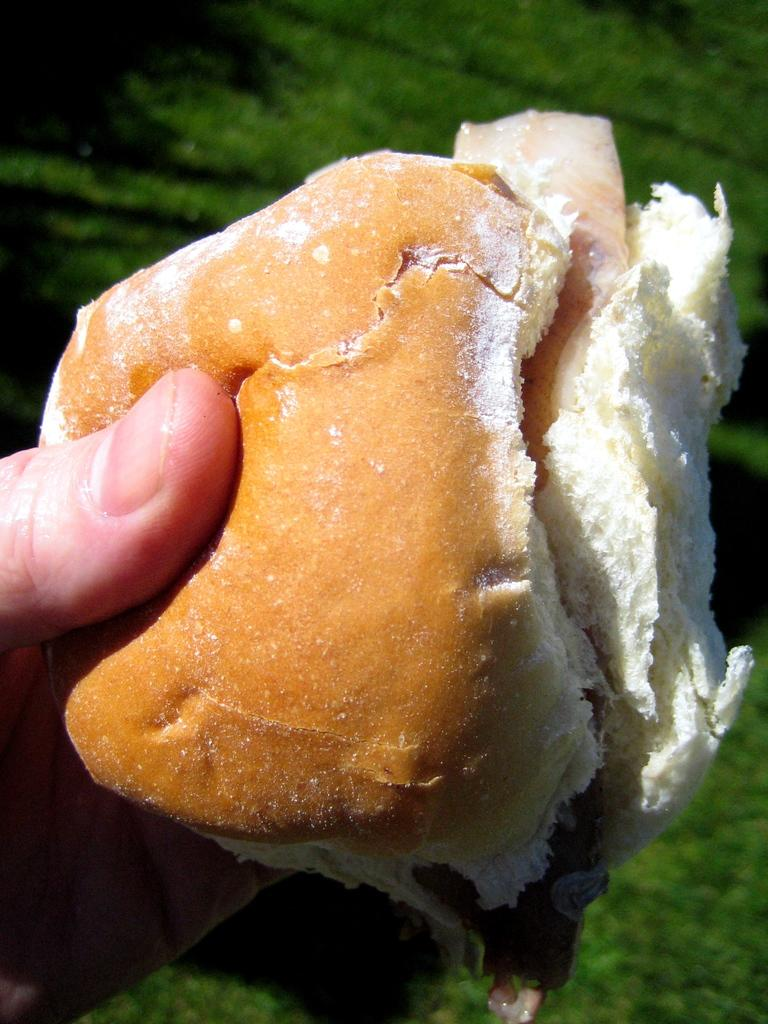What object is being held by someone in the image? There is a food holder in the image that is being held by someone. Can you describe the setting in which the food holder is being held? There is grass visible in the image, suggesting an outdoor setting. What type of prose is being recited by the tree in the image? There is no tree present in the image, nor is there any indication of prose being recited. 